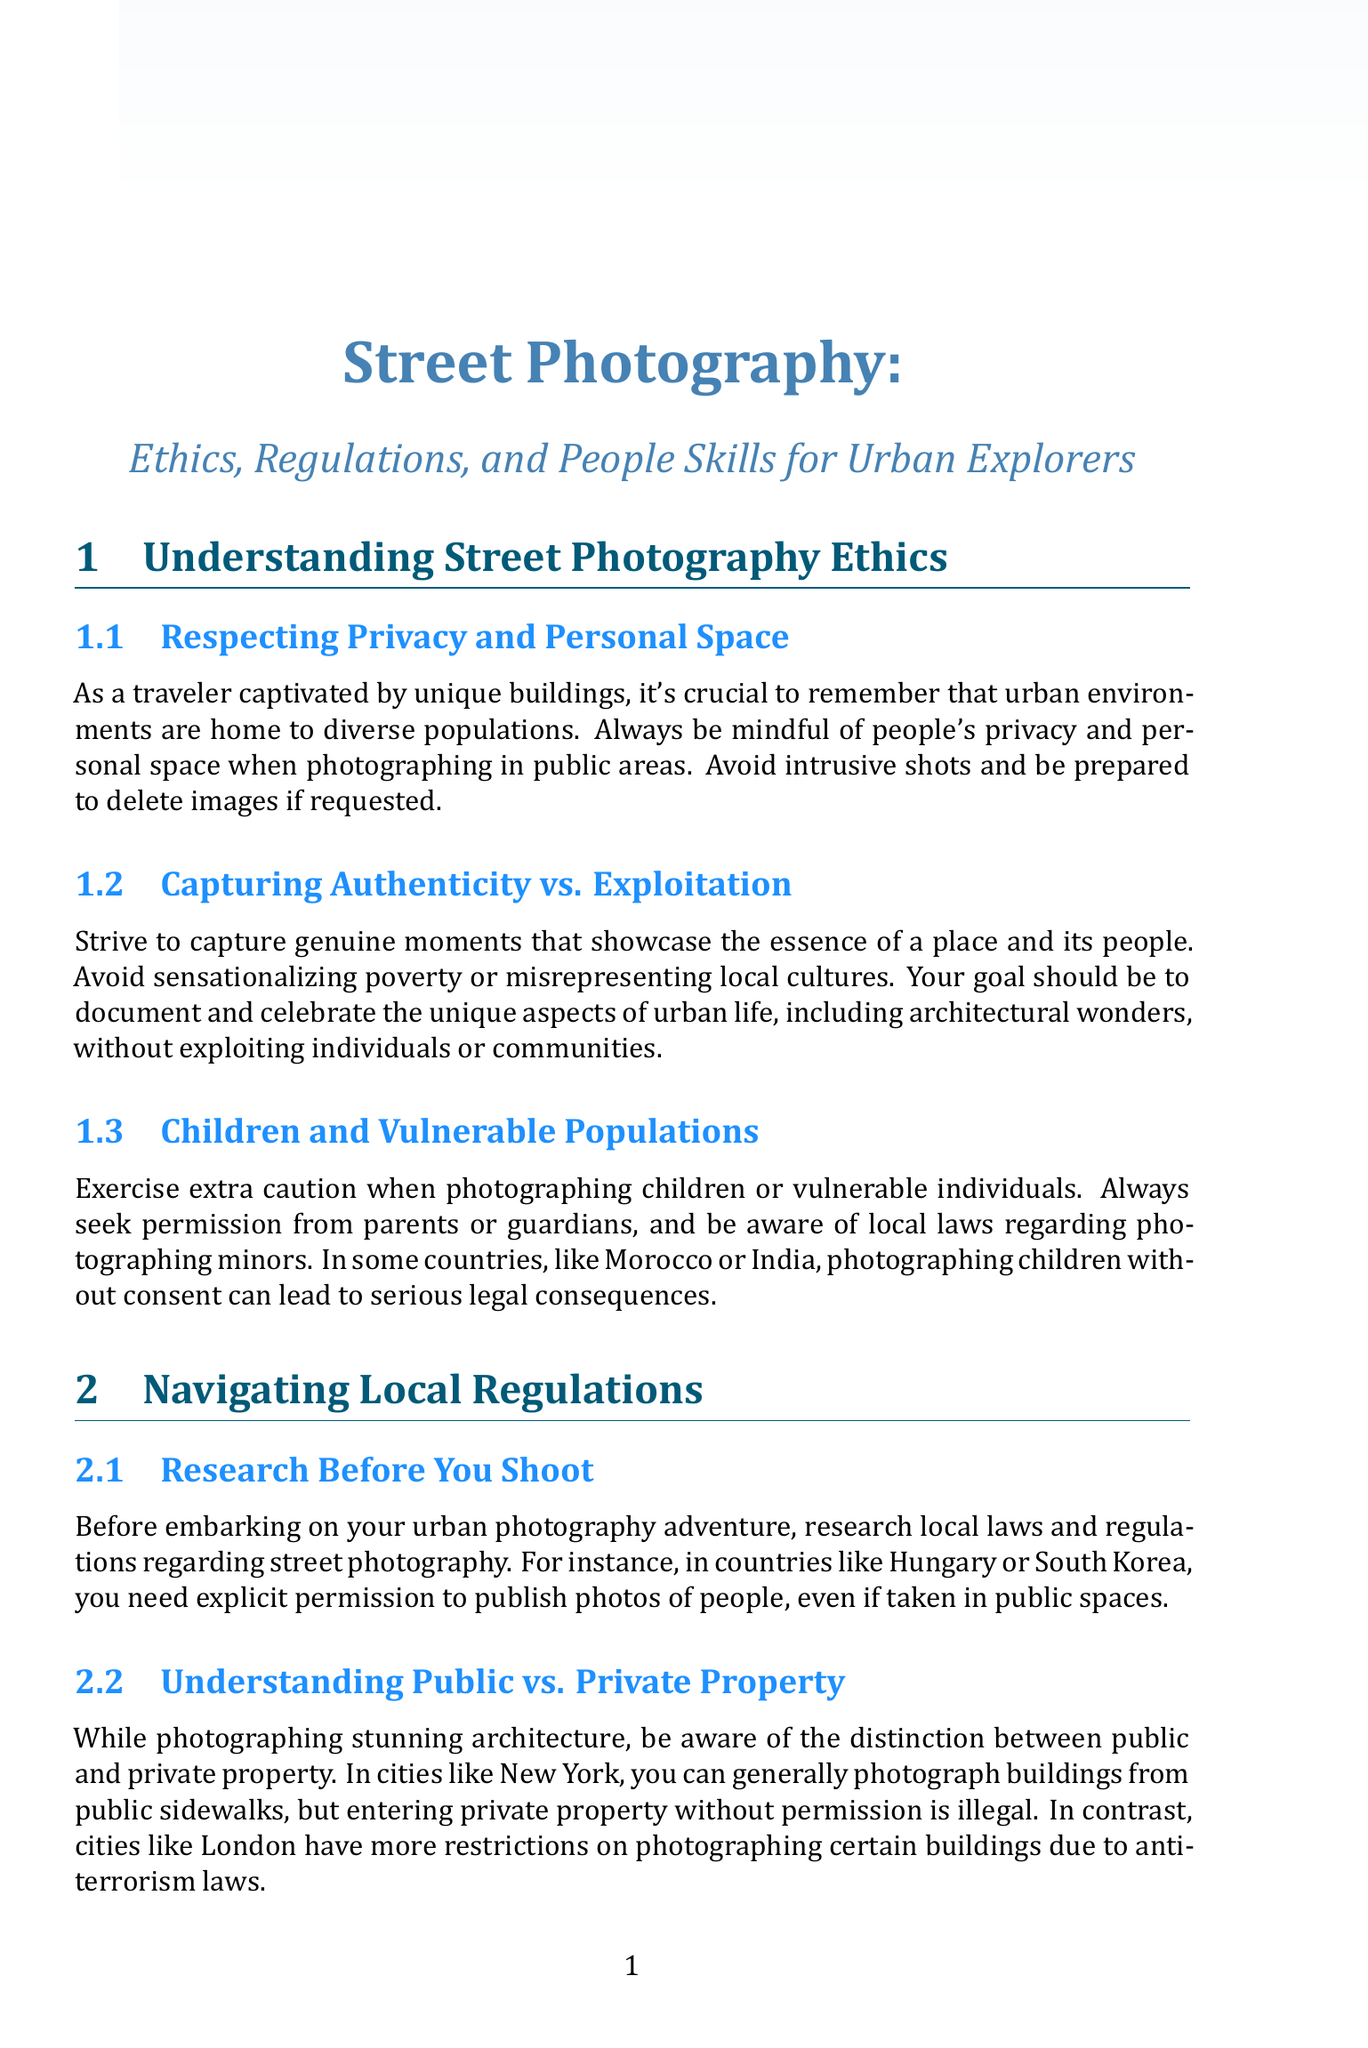what is the title of the document? The title is presented at the beginning of the document, clearly stating the main subject.
Answer: Street Photography: Ethics, Regulations, and People Skills for Urban Explorers how many subsections are there in the section "Tips for Approaching and Photographing People"? The number of subsections can be counted directly in the section mentioned.
Answer: 3 what should you do when photographing children or vulnerable individuals? The document suggests seeking permission from parents or guardians when dealing with sensitive subjects.
Answer: Seek permission what two tools are recommended for post-processing? The tools mentioned in the post-processing considerations section can be found in the respective subsection.
Answer: Adobe Lightroom or Capture One in which countries do you need explicit permission to publish photos of people? The document mentions specific countries in the context of local laws regarding photography.
Answer: Hungary or South Korea what is the recommended lens for architectural photography? The document provides specific lens recommendations in the technical tips section for better architectural shots.
Answer: Canon EF 16-35mm f/4L IS USM which urban features can help create interesting compositions? The document lists various urban characteristics that can enhance photography composition techniques.
Answer: Leading lines, symmetry, and framing 